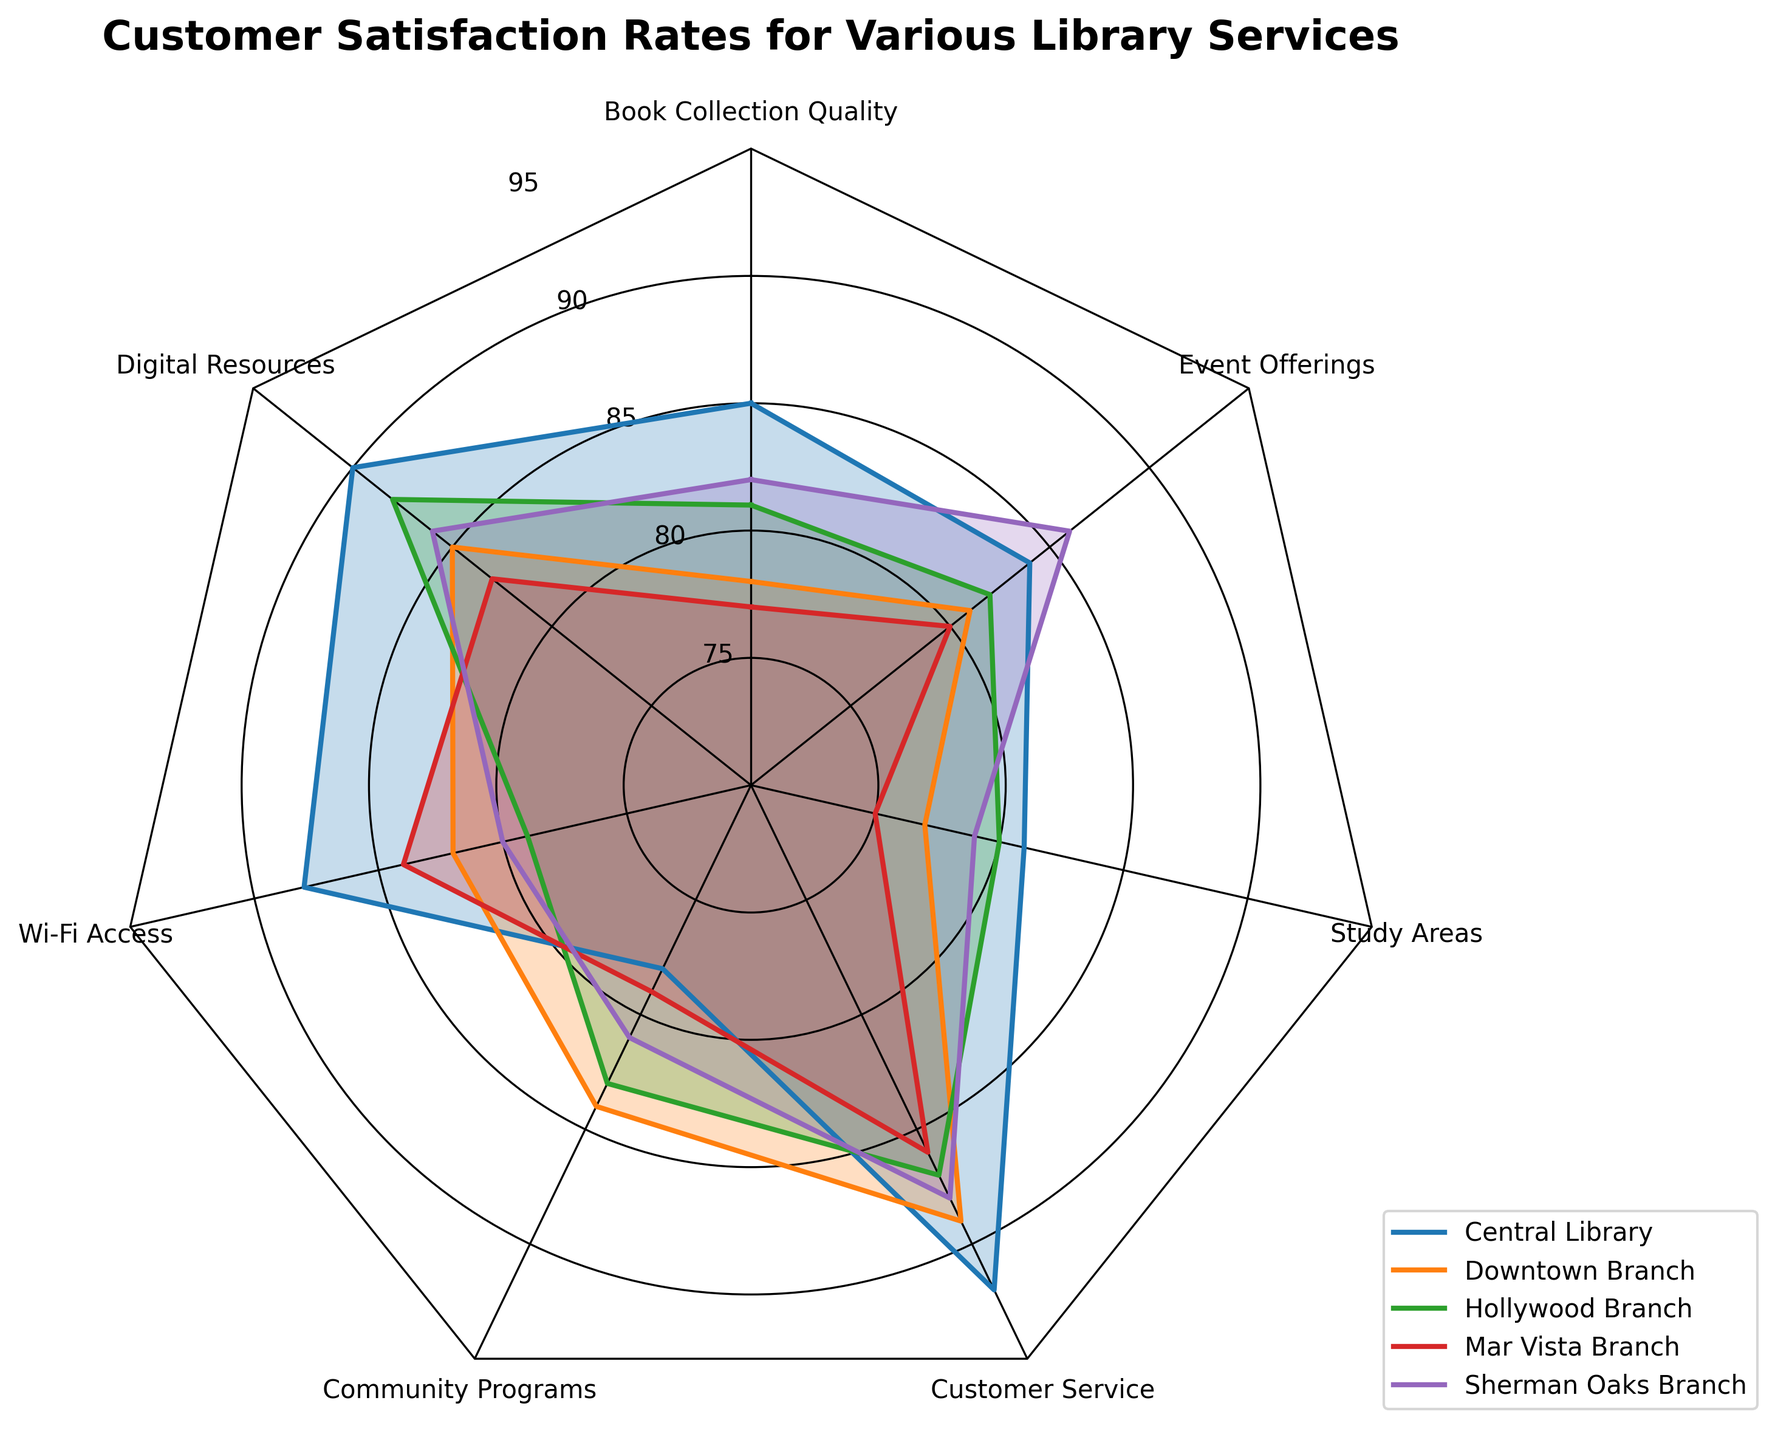what is the title of the chart? The title is generally displayed at the top of the chart. It helps in quickly understanding the focus of the figure. In this case, reading the title directly from the chart provides this information.
Answer: Customer Satisfaction Rates for Various Library Services Which library branch has the highest satisfaction rating for Digital Resources? By looking at the radar chart, you can compare the segment for Digital Resources across different branches. The highest point in this segment indicates the highest satisfaction rating.
Answer: Central Library Which library service category has the lowest satisfaction at the Mar Vista Branch? Locate the Mar Vista Branch data on the chart, then track which service has the lowest value among its plotted points.
Answer: Study Areas How do the satisfaction rates for Wi-Fi Access compare between the Central Library and the Downtown Branch? Identify the segments for Wi-Fi Access for both libraries on the chart, then compare the two values.
Answer: Central Library: 88, Downtown Branch: 82. The Central Library has a higher rating What is the average satisfaction rate for Customer Service across all branches? To find the average, locate the Customer Service ratings for all branches: 92, 89, 87, 86, 88. Add them up and divide by the number of branches. Calculation: (92 + 89 + 87 + 86 + 88) / 5 = 88.4
Answer: 88.4 Which library branch has the most consistent satisfaction rates across all services? Consistency can be determined by the spread of the data points on the radar chart. The branch with the most uniform distances from the center across all services is the most consistent.
Answer: Sherman Oaks Branch How does the satisfaction for Community Programs at the Hollywood Branch compare to the Mar Vista Branch? Check the values of Community Programs for these two branches and compare them directly.
Answer: Hollywood Branch: 83, Mar Vista Branch: 79. Hollywood Branch has higher satisfaction Which two library branches have the closest ratings for Study Areas? Look at the sections for Study Areas across all branches and identify which two are the closest in value.
Answer: Downtown Branch (77) and Sherman Oaks Branch (79) What is the difference in satisfaction rates between the Wi-Fi Access and Event Offerings at the Sherman Oaks Branch? Find the values for Wi-Fi Access and Event Offerings at the Sherman Oaks Branch, and subtract the value of Wi-Fi Access from Event Offerings. Calculation: 86 - 80 = 6
Answer: 6 Among all the library services, which one has the highest overall satisfaction rate when considering all branches? Compare the average satisfaction rates for each service across all branches and identify the highest. Calculation would involve averaging each service across all branches and picking the maximum.
Answer: Customer Service 